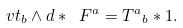Convert formula to latex. <formula><loc_0><loc_0><loc_500><loc_500>\ v t _ { b } \wedge d * \ F ^ { a } = { T ^ { a } } _ { b } * 1 .</formula> 